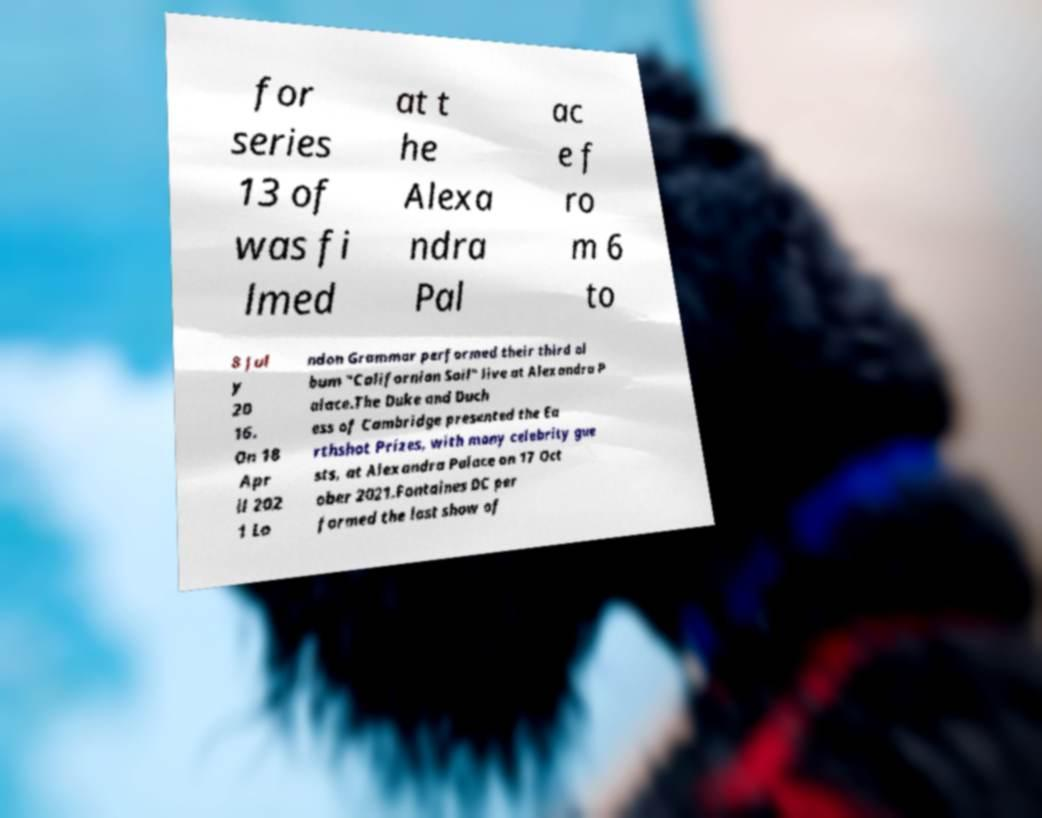I need the written content from this picture converted into text. Can you do that? for series 13 of was fi lmed at t he Alexa ndra Pal ac e f ro m 6 to 8 Jul y 20 16. On 18 Apr il 202 1 Lo ndon Grammar performed their third al bum "Californian Soil" live at Alexandra P alace.The Duke and Duch ess of Cambridge presented the Ea rthshot Prizes, with many celebrity gue sts, at Alexandra Palace on 17 Oct ober 2021.Fontaines DC per formed the last show of 